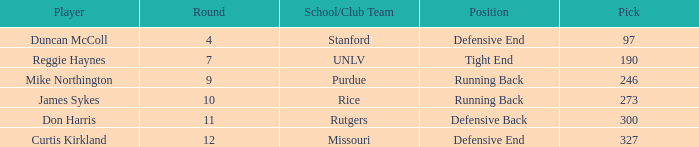Would you mind parsing the complete table? {'header': ['Player', 'Round', 'School/Club Team', 'Position', 'Pick'], 'rows': [['Duncan McColl', '4', 'Stanford', 'Defensive End', '97'], ['Reggie Haynes', '7', 'UNLV', 'Tight End', '190'], ['Mike Northington', '9', 'Purdue', 'Running Back', '246'], ['James Sykes', '10', 'Rice', 'Running Back', '273'], ['Don Harris', '11', 'Rutgers', 'Defensive Back', '300'], ['Curtis Kirkland', '12', 'Missouri', 'Defensive End', '327']]} What is the total number of rounds that had draft pick 97, duncan mccoll? 0.0. 